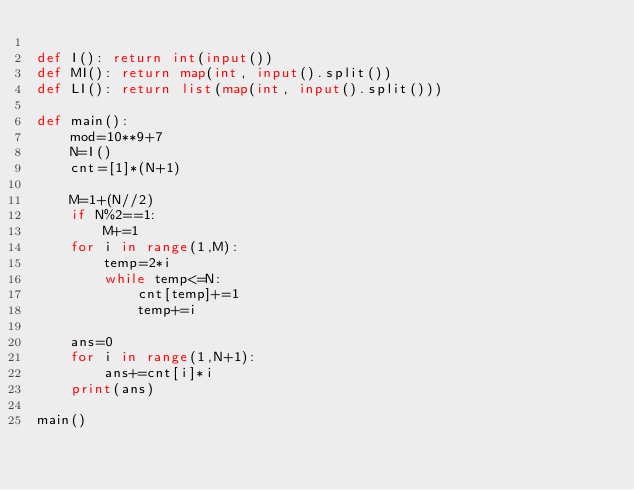Convert code to text. <code><loc_0><loc_0><loc_500><loc_500><_Python_>
def I(): return int(input())
def MI(): return map(int, input().split())
def LI(): return list(map(int, input().split()))

def main():
    mod=10**9+7
    N=I()
    cnt=[1]*(N+1)
    
    M=1+(N//2)
    if N%2==1:
        M+=1
    for i in range(1,M):
        temp=2*i
        while temp<=N:
            cnt[temp]+=1
            temp+=i
            
    ans=0
    for i in range(1,N+1):
        ans+=cnt[i]*i
    print(ans)

main()
</code> 